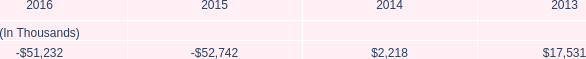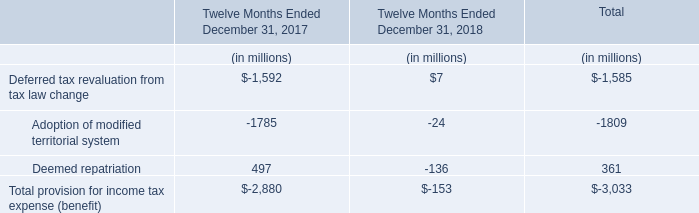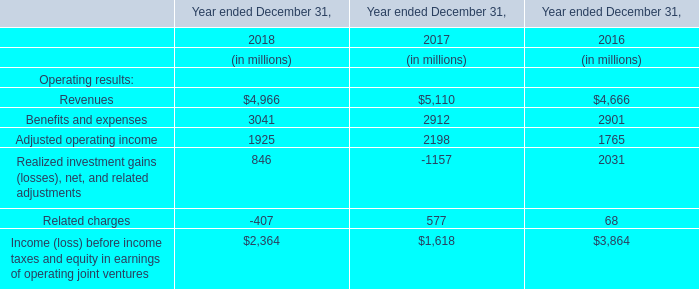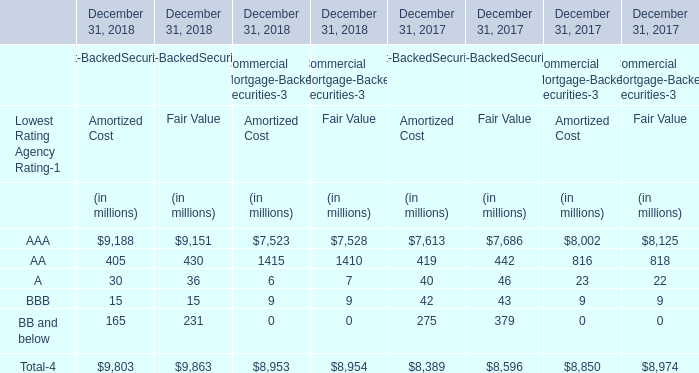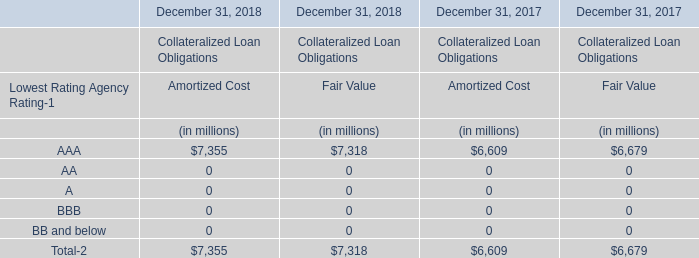What is the total value of AAA, AA, A and BBB for Amortized Cost in 2018 ? (in million) 
Computations: (((7355 + 0) + 0) + 0)
Answer: 7355.0. 